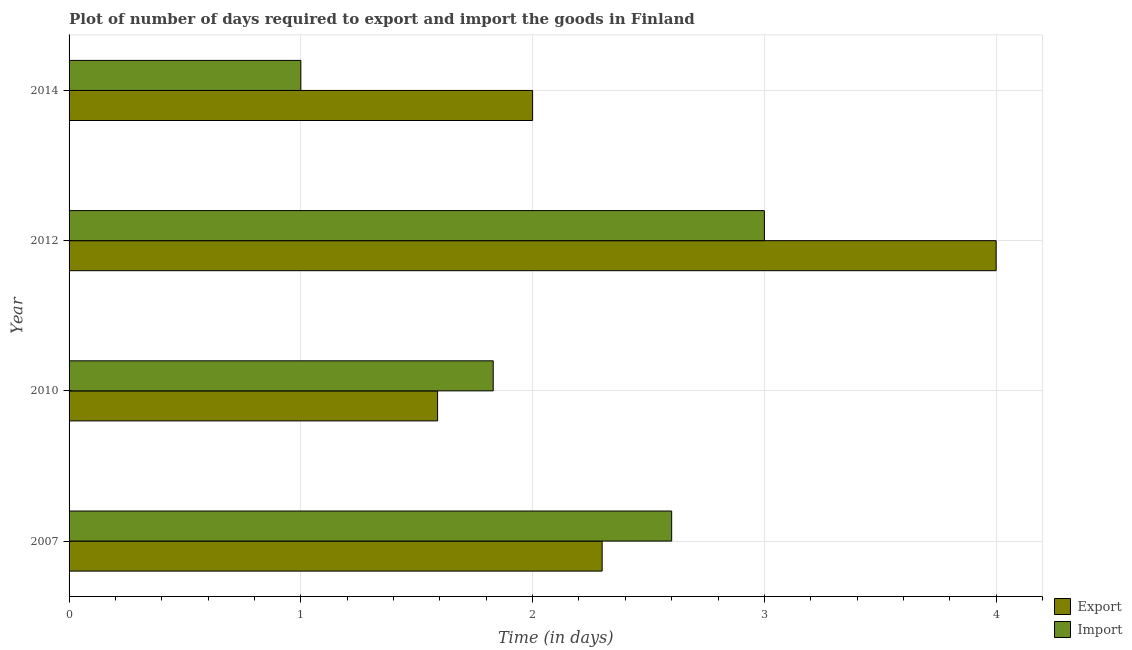Are the number of bars on each tick of the Y-axis equal?
Your answer should be compact. Yes. How many bars are there on the 2nd tick from the bottom?
Provide a short and direct response. 2. In how many cases, is the number of bars for a given year not equal to the number of legend labels?
Offer a very short reply. 0. What is the time required to export in 2010?
Give a very brief answer. 1.59. Across all years, what is the maximum time required to export?
Give a very brief answer. 4. Across all years, what is the minimum time required to import?
Your answer should be compact. 1. In which year was the time required to export maximum?
Make the answer very short. 2012. What is the total time required to export in the graph?
Your answer should be compact. 9.89. What is the difference between the time required to import in 2007 and that in 2012?
Your answer should be compact. -0.4. What is the average time required to import per year?
Your answer should be compact. 2.11. In the year 2010, what is the difference between the time required to export and time required to import?
Your answer should be compact. -0.24. In how many years, is the time required to export greater than 1.6 days?
Your answer should be compact. 3. What is the ratio of the time required to export in 2010 to that in 2014?
Provide a succinct answer. 0.8. Is the time required to import in 2007 less than that in 2012?
Offer a very short reply. Yes. Is the difference between the time required to export in 2012 and 2014 greater than the difference between the time required to import in 2012 and 2014?
Keep it short and to the point. No. What is the difference between the highest and the lowest time required to import?
Provide a succinct answer. 2. In how many years, is the time required to import greater than the average time required to import taken over all years?
Make the answer very short. 2. Is the sum of the time required to export in 2012 and 2014 greater than the maximum time required to import across all years?
Offer a very short reply. Yes. What does the 1st bar from the top in 2012 represents?
Make the answer very short. Import. What does the 1st bar from the bottom in 2007 represents?
Provide a succinct answer. Export. How many bars are there?
Your answer should be very brief. 8. How many years are there in the graph?
Offer a terse response. 4. What is the difference between two consecutive major ticks on the X-axis?
Give a very brief answer. 1. How are the legend labels stacked?
Your answer should be compact. Vertical. What is the title of the graph?
Your answer should be very brief. Plot of number of days required to export and import the goods in Finland. What is the label or title of the X-axis?
Make the answer very short. Time (in days). What is the label or title of the Y-axis?
Offer a very short reply. Year. What is the Time (in days) of Export in 2007?
Provide a short and direct response. 2.3. What is the Time (in days) in Import in 2007?
Your answer should be very brief. 2.6. What is the Time (in days) in Export in 2010?
Provide a short and direct response. 1.59. What is the Time (in days) in Import in 2010?
Your response must be concise. 1.83. What is the Time (in days) of Export in 2014?
Make the answer very short. 2. Across all years, what is the maximum Time (in days) in Import?
Offer a very short reply. 3. Across all years, what is the minimum Time (in days) of Export?
Your answer should be very brief. 1.59. Across all years, what is the minimum Time (in days) of Import?
Ensure brevity in your answer.  1. What is the total Time (in days) of Export in the graph?
Your response must be concise. 9.89. What is the total Time (in days) in Import in the graph?
Your answer should be compact. 8.43. What is the difference between the Time (in days) in Export in 2007 and that in 2010?
Give a very brief answer. 0.71. What is the difference between the Time (in days) in Import in 2007 and that in 2010?
Provide a short and direct response. 0.77. What is the difference between the Time (in days) of Import in 2007 and that in 2014?
Give a very brief answer. 1.6. What is the difference between the Time (in days) of Export in 2010 and that in 2012?
Give a very brief answer. -2.41. What is the difference between the Time (in days) in Import in 2010 and that in 2012?
Your answer should be very brief. -1.17. What is the difference between the Time (in days) in Export in 2010 and that in 2014?
Make the answer very short. -0.41. What is the difference between the Time (in days) in Import in 2010 and that in 2014?
Your answer should be compact. 0.83. What is the difference between the Time (in days) in Export in 2007 and the Time (in days) in Import in 2010?
Offer a terse response. 0.47. What is the difference between the Time (in days) in Export in 2007 and the Time (in days) in Import in 2014?
Make the answer very short. 1.3. What is the difference between the Time (in days) in Export in 2010 and the Time (in days) in Import in 2012?
Provide a succinct answer. -1.41. What is the difference between the Time (in days) in Export in 2010 and the Time (in days) in Import in 2014?
Offer a terse response. 0.59. What is the average Time (in days) of Export per year?
Provide a short and direct response. 2.47. What is the average Time (in days) in Import per year?
Your answer should be compact. 2.11. In the year 2010, what is the difference between the Time (in days) in Export and Time (in days) in Import?
Offer a terse response. -0.24. In the year 2012, what is the difference between the Time (in days) in Export and Time (in days) in Import?
Give a very brief answer. 1. What is the ratio of the Time (in days) of Export in 2007 to that in 2010?
Provide a short and direct response. 1.45. What is the ratio of the Time (in days) in Import in 2007 to that in 2010?
Provide a succinct answer. 1.42. What is the ratio of the Time (in days) in Export in 2007 to that in 2012?
Ensure brevity in your answer.  0.57. What is the ratio of the Time (in days) of Import in 2007 to that in 2012?
Your answer should be very brief. 0.87. What is the ratio of the Time (in days) of Export in 2007 to that in 2014?
Your response must be concise. 1.15. What is the ratio of the Time (in days) in Import in 2007 to that in 2014?
Keep it short and to the point. 2.6. What is the ratio of the Time (in days) in Export in 2010 to that in 2012?
Provide a succinct answer. 0.4. What is the ratio of the Time (in days) of Import in 2010 to that in 2012?
Provide a succinct answer. 0.61. What is the ratio of the Time (in days) of Export in 2010 to that in 2014?
Offer a terse response. 0.8. What is the ratio of the Time (in days) of Import in 2010 to that in 2014?
Keep it short and to the point. 1.83. What is the ratio of the Time (in days) in Import in 2012 to that in 2014?
Give a very brief answer. 3. What is the difference between the highest and the lowest Time (in days) in Export?
Provide a succinct answer. 2.41. 